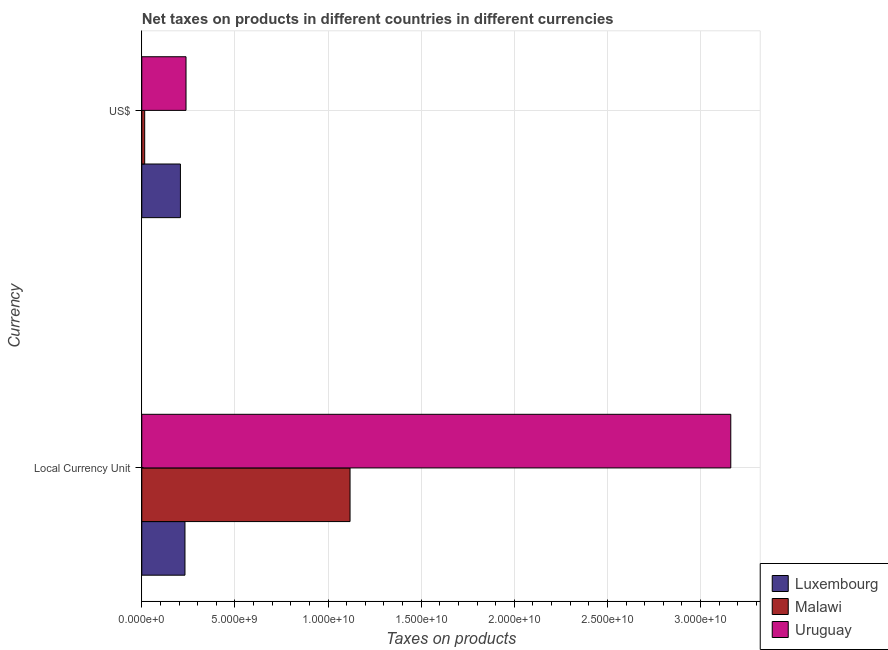How many groups of bars are there?
Your response must be concise. 2. Are the number of bars on each tick of the Y-axis equal?
Make the answer very short. Yes. How many bars are there on the 2nd tick from the bottom?
Make the answer very short. 3. What is the label of the 2nd group of bars from the top?
Your response must be concise. Local Currency Unit. What is the net taxes in constant 2005 us$ in Luxembourg?
Give a very brief answer. 2.32e+09. Across all countries, what is the maximum net taxes in us$?
Ensure brevity in your answer.  2.37e+09. Across all countries, what is the minimum net taxes in us$?
Provide a succinct answer. 1.55e+08. In which country was the net taxes in constant 2005 us$ maximum?
Keep it short and to the point. Uruguay. In which country was the net taxes in constant 2005 us$ minimum?
Keep it short and to the point. Luxembourg. What is the total net taxes in us$ in the graph?
Keep it short and to the point. 4.60e+09. What is the difference between the net taxes in constant 2005 us$ in Uruguay and that in Luxembourg?
Provide a short and direct response. 2.93e+1. What is the difference between the net taxes in us$ in Uruguay and the net taxes in constant 2005 us$ in Malawi?
Ensure brevity in your answer.  -8.81e+09. What is the average net taxes in us$ per country?
Offer a very short reply. 1.53e+09. What is the difference between the net taxes in constant 2005 us$ and net taxes in us$ in Luxembourg?
Make the answer very short. 2.44e+08. In how many countries, is the net taxes in constant 2005 us$ greater than 13000000000 units?
Provide a short and direct response. 1. What is the ratio of the net taxes in us$ in Luxembourg to that in Malawi?
Give a very brief answer. 13.39. Is the net taxes in us$ in Uruguay less than that in Malawi?
Make the answer very short. No. What does the 1st bar from the top in Local Currency Unit represents?
Offer a very short reply. Uruguay. What does the 3rd bar from the bottom in US$ represents?
Give a very brief answer. Uruguay. Are the values on the major ticks of X-axis written in scientific E-notation?
Give a very brief answer. Yes. Does the graph contain grids?
Give a very brief answer. Yes. How are the legend labels stacked?
Provide a short and direct response. Vertical. What is the title of the graph?
Offer a terse response. Net taxes on products in different countries in different currencies. Does "Sierra Leone" appear as one of the legend labels in the graph?
Your response must be concise. No. What is the label or title of the X-axis?
Your response must be concise. Taxes on products. What is the label or title of the Y-axis?
Provide a short and direct response. Currency. What is the Taxes on products in Luxembourg in Local Currency Unit?
Make the answer very short. 2.32e+09. What is the Taxes on products in Malawi in Local Currency Unit?
Your answer should be very brief. 1.12e+1. What is the Taxes on products of Uruguay in Local Currency Unit?
Offer a very short reply. 3.16e+1. What is the Taxes on products of Luxembourg in US$?
Your answer should be compact. 2.07e+09. What is the Taxes on products of Malawi in US$?
Make the answer very short. 1.55e+08. What is the Taxes on products in Uruguay in US$?
Provide a short and direct response. 2.37e+09. Across all Currency, what is the maximum Taxes on products of Luxembourg?
Your answer should be compact. 2.32e+09. Across all Currency, what is the maximum Taxes on products in Malawi?
Ensure brevity in your answer.  1.12e+1. Across all Currency, what is the maximum Taxes on products in Uruguay?
Provide a short and direct response. 3.16e+1. Across all Currency, what is the minimum Taxes on products in Luxembourg?
Provide a succinct answer. 2.07e+09. Across all Currency, what is the minimum Taxes on products in Malawi?
Ensure brevity in your answer.  1.55e+08. Across all Currency, what is the minimum Taxes on products of Uruguay?
Make the answer very short. 2.37e+09. What is the total Taxes on products of Luxembourg in the graph?
Provide a succinct answer. 4.39e+09. What is the total Taxes on products of Malawi in the graph?
Your answer should be very brief. 1.13e+1. What is the total Taxes on products of Uruguay in the graph?
Offer a terse response. 3.40e+1. What is the difference between the Taxes on products in Luxembourg in Local Currency Unit and that in US$?
Offer a terse response. 2.44e+08. What is the difference between the Taxes on products of Malawi in Local Currency Unit and that in US$?
Provide a short and direct response. 1.10e+1. What is the difference between the Taxes on products of Uruguay in Local Currency Unit and that in US$?
Provide a short and direct response. 2.93e+1. What is the difference between the Taxes on products of Luxembourg in Local Currency Unit and the Taxes on products of Malawi in US$?
Make the answer very short. 2.16e+09. What is the difference between the Taxes on products in Luxembourg in Local Currency Unit and the Taxes on products in Uruguay in US$?
Your answer should be compact. -5.66e+07. What is the difference between the Taxes on products of Malawi in Local Currency Unit and the Taxes on products of Uruguay in US$?
Ensure brevity in your answer.  8.81e+09. What is the average Taxes on products of Luxembourg per Currency?
Offer a terse response. 2.20e+09. What is the average Taxes on products of Malawi per Currency?
Offer a very short reply. 5.67e+09. What is the average Taxes on products of Uruguay per Currency?
Give a very brief answer. 1.70e+1. What is the difference between the Taxes on products of Luxembourg and Taxes on products of Malawi in Local Currency Unit?
Offer a terse response. -8.86e+09. What is the difference between the Taxes on products of Luxembourg and Taxes on products of Uruguay in Local Currency Unit?
Your response must be concise. -2.93e+1. What is the difference between the Taxes on products in Malawi and Taxes on products in Uruguay in Local Currency Unit?
Offer a very short reply. -2.04e+1. What is the difference between the Taxes on products of Luxembourg and Taxes on products of Malawi in US$?
Make the answer very short. 1.92e+09. What is the difference between the Taxes on products of Luxembourg and Taxes on products of Uruguay in US$?
Provide a succinct answer. -3.00e+08. What is the difference between the Taxes on products in Malawi and Taxes on products in Uruguay in US$?
Your answer should be compact. -2.22e+09. What is the ratio of the Taxes on products in Luxembourg in Local Currency Unit to that in US$?
Your answer should be very brief. 1.12. What is the ratio of the Taxes on products of Malawi in Local Currency Unit to that in US$?
Provide a short and direct response. 72.2. What is the ratio of the Taxes on products in Uruguay in Local Currency Unit to that in US$?
Your response must be concise. 13.32. What is the difference between the highest and the second highest Taxes on products of Luxembourg?
Keep it short and to the point. 2.44e+08. What is the difference between the highest and the second highest Taxes on products in Malawi?
Offer a very short reply. 1.10e+1. What is the difference between the highest and the second highest Taxes on products of Uruguay?
Offer a terse response. 2.93e+1. What is the difference between the highest and the lowest Taxes on products of Luxembourg?
Keep it short and to the point. 2.44e+08. What is the difference between the highest and the lowest Taxes on products in Malawi?
Your response must be concise. 1.10e+1. What is the difference between the highest and the lowest Taxes on products in Uruguay?
Your answer should be very brief. 2.93e+1. 